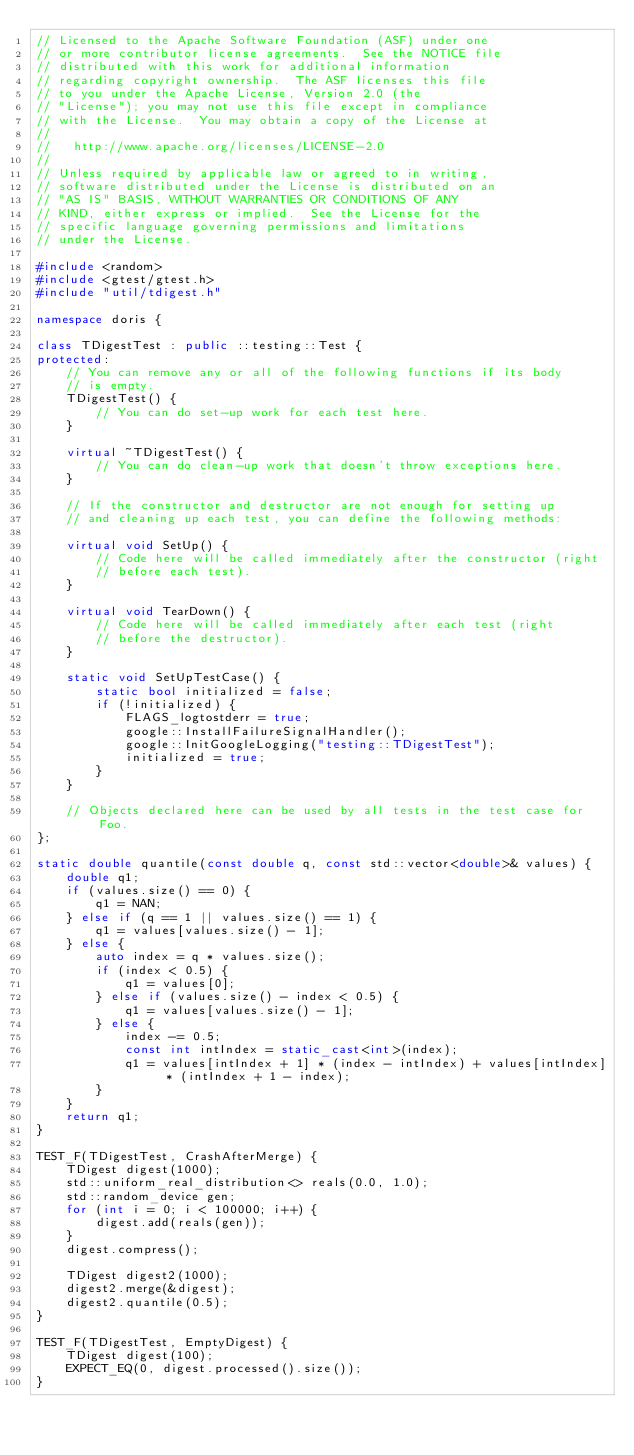Convert code to text. <code><loc_0><loc_0><loc_500><loc_500><_C++_>// Licensed to the Apache Software Foundation (ASF) under one
// or more contributor license agreements.  See the NOTICE file
// distributed with this work for additional information
// regarding copyright ownership.  The ASF licenses this file
// to you under the Apache License, Version 2.0 (the
// "License"); you may not use this file except in compliance
// with the License.  You may obtain a copy of the License at
//
//   http://www.apache.org/licenses/LICENSE-2.0
//
// Unless required by applicable law or agreed to in writing,
// software distributed under the License is distributed on an
// "AS IS" BASIS, WITHOUT WARRANTIES OR CONDITIONS OF ANY
// KIND, either express or implied.  See the License for the
// specific language governing permissions and limitations
// under the License.

#include <random>
#include <gtest/gtest.h>
#include "util/tdigest.h"

namespace doris {

class TDigestTest : public ::testing::Test {
protected:
    // You can remove any or all of the following functions if its body
    // is empty.
    TDigestTest() {
        // You can do set-up work for each test here.
    }

    virtual ~TDigestTest() {
        // You can do clean-up work that doesn't throw exceptions here.
    }

    // If the constructor and destructor are not enough for setting up
    // and cleaning up each test, you can define the following methods:

    virtual void SetUp() {
        // Code here will be called immediately after the constructor (right
        // before each test).
    }

    virtual void TearDown() {
        // Code here will be called immediately after each test (right
        // before the destructor).
    }

    static void SetUpTestCase() {
        static bool initialized = false;
        if (!initialized) {
            FLAGS_logtostderr = true;
            google::InstallFailureSignalHandler();
            google::InitGoogleLogging("testing::TDigestTest");
            initialized = true;
        }
    }

    // Objects declared here can be used by all tests in the test case for Foo.
};

static double quantile(const double q, const std::vector<double>& values) {
    double q1;
    if (values.size() == 0) {
        q1 = NAN;
    } else if (q == 1 || values.size() == 1) {
        q1 = values[values.size() - 1];
    } else {
        auto index = q * values.size();
        if (index < 0.5) {
            q1 = values[0];
        } else if (values.size() - index < 0.5) {
            q1 = values[values.size() - 1];
        } else {
            index -= 0.5;
            const int intIndex = static_cast<int>(index);
            q1 = values[intIndex + 1] * (index - intIndex) + values[intIndex] * (intIndex + 1 - index);
        }
    }
    return q1;
}

TEST_F(TDigestTest, CrashAfterMerge) {
    TDigest digest(1000);
    std::uniform_real_distribution<> reals(0.0, 1.0);
    std::random_device gen;
    for (int i = 0; i < 100000; i++) {
        digest.add(reals(gen));
    }
    digest.compress();

    TDigest digest2(1000);
    digest2.merge(&digest);
    digest2.quantile(0.5);
}

TEST_F(TDigestTest, EmptyDigest) {
    TDigest digest(100);
    EXPECT_EQ(0, digest.processed().size());
}
</code> 